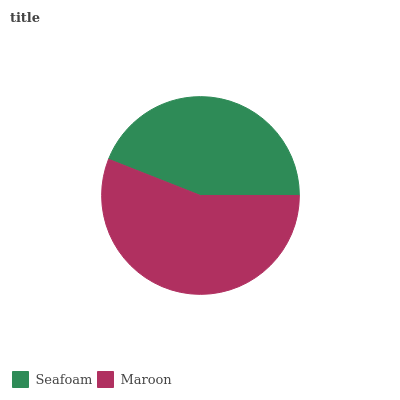Is Seafoam the minimum?
Answer yes or no. Yes. Is Maroon the maximum?
Answer yes or no. Yes. Is Maroon the minimum?
Answer yes or no. No. Is Maroon greater than Seafoam?
Answer yes or no. Yes. Is Seafoam less than Maroon?
Answer yes or no. Yes. Is Seafoam greater than Maroon?
Answer yes or no. No. Is Maroon less than Seafoam?
Answer yes or no. No. Is Maroon the high median?
Answer yes or no. Yes. Is Seafoam the low median?
Answer yes or no. Yes. Is Seafoam the high median?
Answer yes or no. No. Is Maroon the low median?
Answer yes or no. No. 